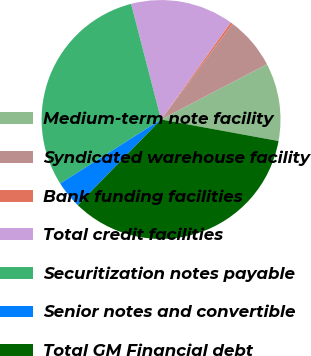Convert chart to OTSL. <chart><loc_0><loc_0><loc_500><loc_500><pie_chart><fcel>Medium-term note facility<fcel>Syndicated warehouse facility<fcel>Bank funding facilities<fcel>Total credit facilities<fcel>Securitization notes payable<fcel>Senior notes and convertible<fcel>Total GM Financial debt<nl><fcel>10.54%<fcel>7.13%<fcel>0.31%<fcel>13.94%<fcel>29.97%<fcel>3.72%<fcel>34.39%<nl></chart> 